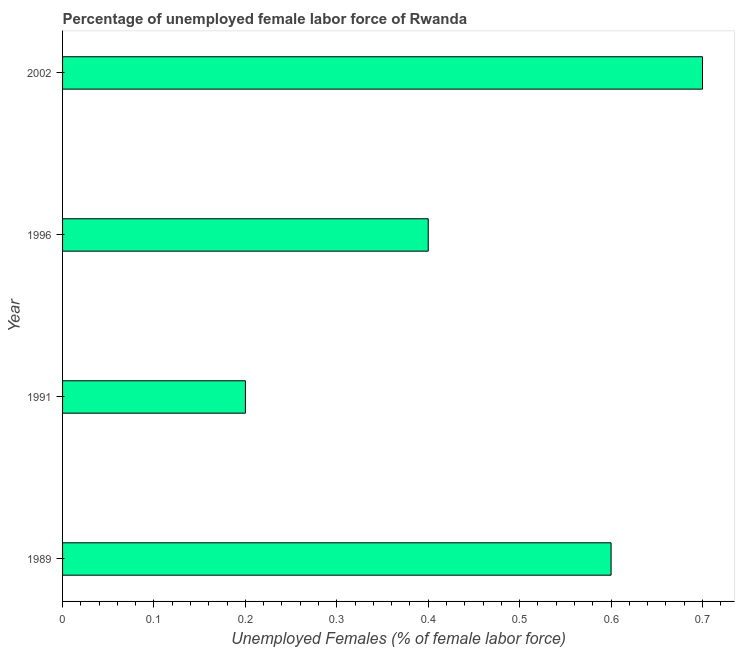What is the title of the graph?
Make the answer very short. Percentage of unemployed female labor force of Rwanda. What is the label or title of the X-axis?
Offer a terse response. Unemployed Females (% of female labor force). What is the label or title of the Y-axis?
Offer a terse response. Year. What is the total unemployed female labour force in 1996?
Offer a terse response. 0.4. Across all years, what is the maximum total unemployed female labour force?
Provide a short and direct response. 0.7. Across all years, what is the minimum total unemployed female labour force?
Keep it short and to the point. 0.2. In which year was the total unemployed female labour force maximum?
Your response must be concise. 2002. In which year was the total unemployed female labour force minimum?
Your response must be concise. 1991. What is the sum of the total unemployed female labour force?
Offer a very short reply. 1.9. What is the difference between the total unemployed female labour force in 1991 and 1996?
Make the answer very short. -0.2. What is the average total unemployed female labour force per year?
Your answer should be very brief. 0.47. What is the median total unemployed female labour force?
Offer a terse response. 0.5. Do a majority of the years between 1991 and 1989 (inclusive) have total unemployed female labour force greater than 0.5 %?
Provide a succinct answer. No. What is the ratio of the total unemployed female labour force in 1991 to that in 2002?
Give a very brief answer. 0.29. What is the difference between the highest and the second highest total unemployed female labour force?
Give a very brief answer. 0.1. In how many years, is the total unemployed female labour force greater than the average total unemployed female labour force taken over all years?
Make the answer very short. 2. How many bars are there?
Make the answer very short. 4. Are the values on the major ticks of X-axis written in scientific E-notation?
Offer a very short reply. No. What is the Unemployed Females (% of female labor force) of 1989?
Keep it short and to the point. 0.6. What is the Unemployed Females (% of female labor force) in 1991?
Provide a succinct answer. 0.2. What is the Unemployed Females (% of female labor force) of 1996?
Your response must be concise. 0.4. What is the Unemployed Females (% of female labor force) in 2002?
Offer a terse response. 0.7. What is the difference between the Unemployed Females (% of female labor force) in 1989 and 1991?
Offer a terse response. 0.4. What is the difference between the Unemployed Females (% of female labor force) in 1989 and 1996?
Make the answer very short. 0.2. What is the difference between the Unemployed Females (% of female labor force) in 1989 and 2002?
Provide a short and direct response. -0.1. What is the difference between the Unemployed Females (% of female labor force) in 1991 and 1996?
Ensure brevity in your answer.  -0.2. What is the difference between the Unemployed Females (% of female labor force) in 1991 and 2002?
Provide a succinct answer. -0.5. What is the ratio of the Unemployed Females (% of female labor force) in 1989 to that in 1996?
Offer a very short reply. 1.5. What is the ratio of the Unemployed Females (% of female labor force) in 1989 to that in 2002?
Provide a short and direct response. 0.86. What is the ratio of the Unemployed Females (% of female labor force) in 1991 to that in 1996?
Your answer should be very brief. 0.5. What is the ratio of the Unemployed Females (% of female labor force) in 1991 to that in 2002?
Ensure brevity in your answer.  0.29. What is the ratio of the Unemployed Females (% of female labor force) in 1996 to that in 2002?
Offer a terse response. 0.57. 